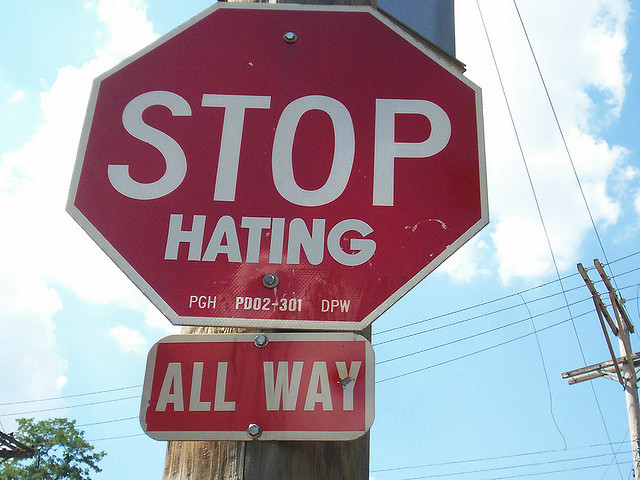<image>What time is it according to the sign? The sign does not provide the time. What time is it according to the sign? The sign doesn't say the time. There is no indication of the time according to the sign. 